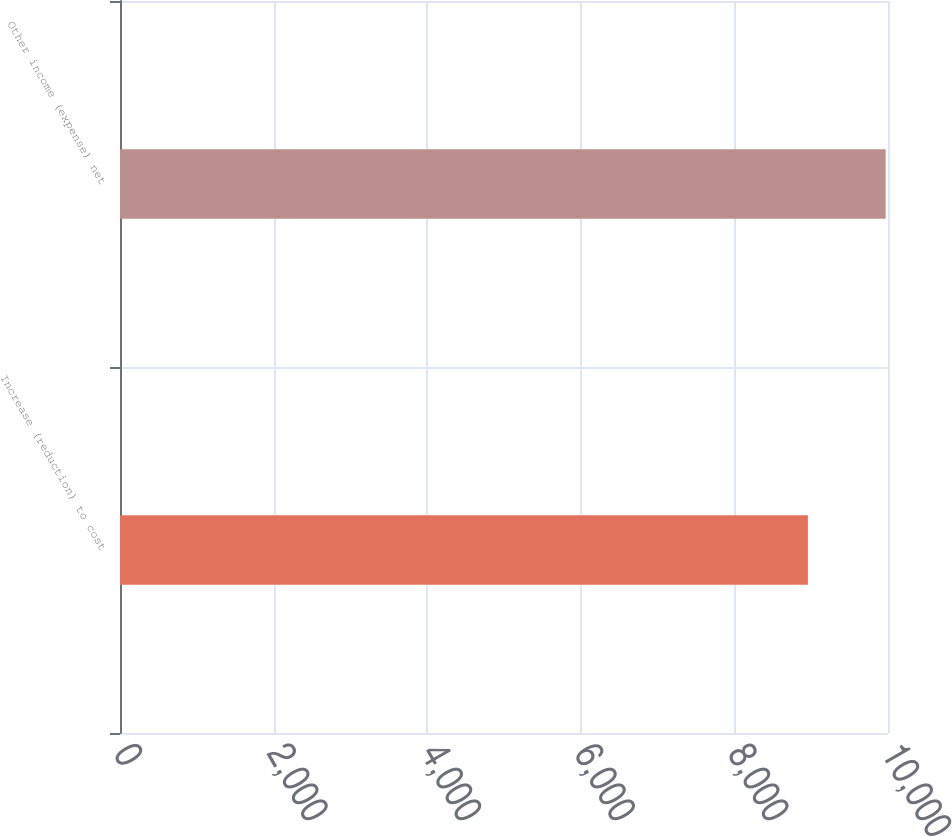Convert chart. <chart><loc_0><loc_0><loc_500><loc_500><bar_chart><fcel>Increase (reduction) to cost<fcel>Other income (expense) net<nl><fcel>8957<fcel>9969<nl></chart> 